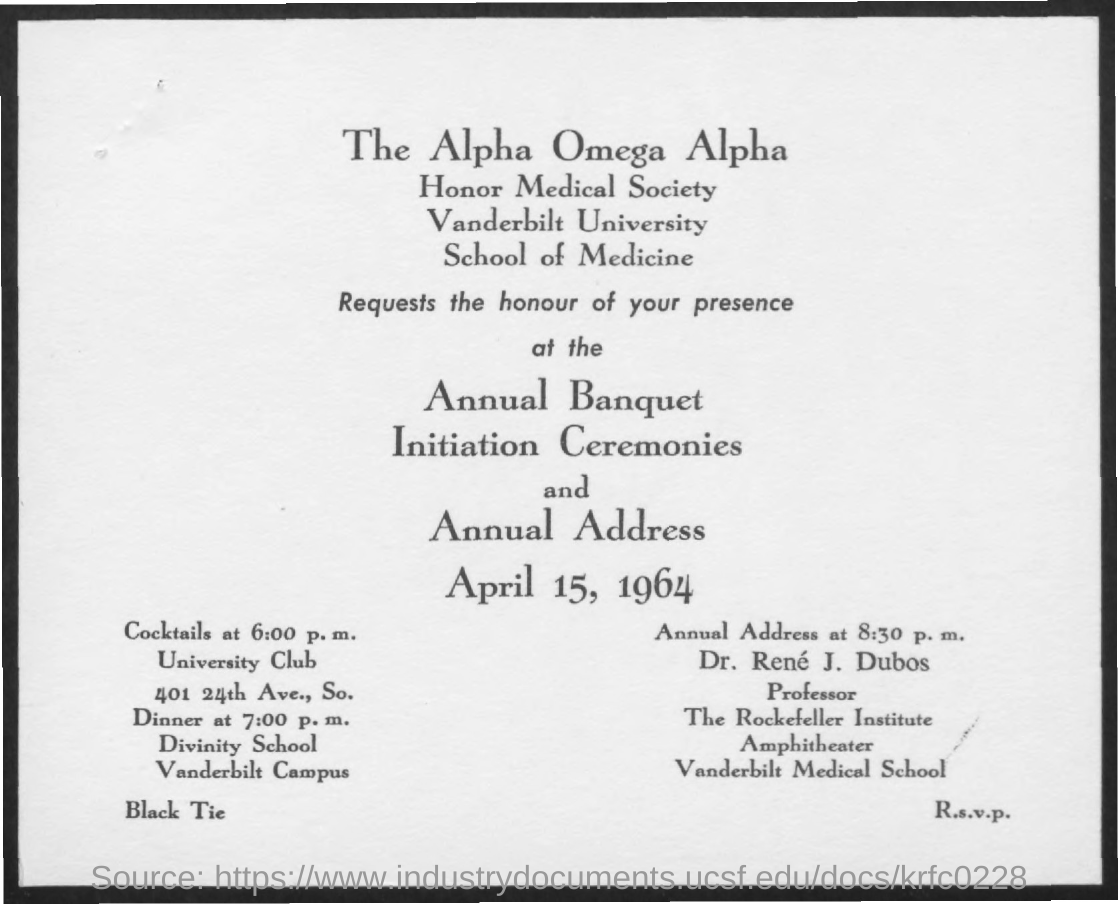Give some essential details in this illustration. Vanderbilt University conducts the program on April 15. Vanderbilt University has an Honor Medical Society as part of its society. I attended Divinity School, where dinner was arranged. Dr. Rene J. Dubos is a professor at Vanderbilt Medical School, where he works. The annual address was conducted on April 15, 1964. 